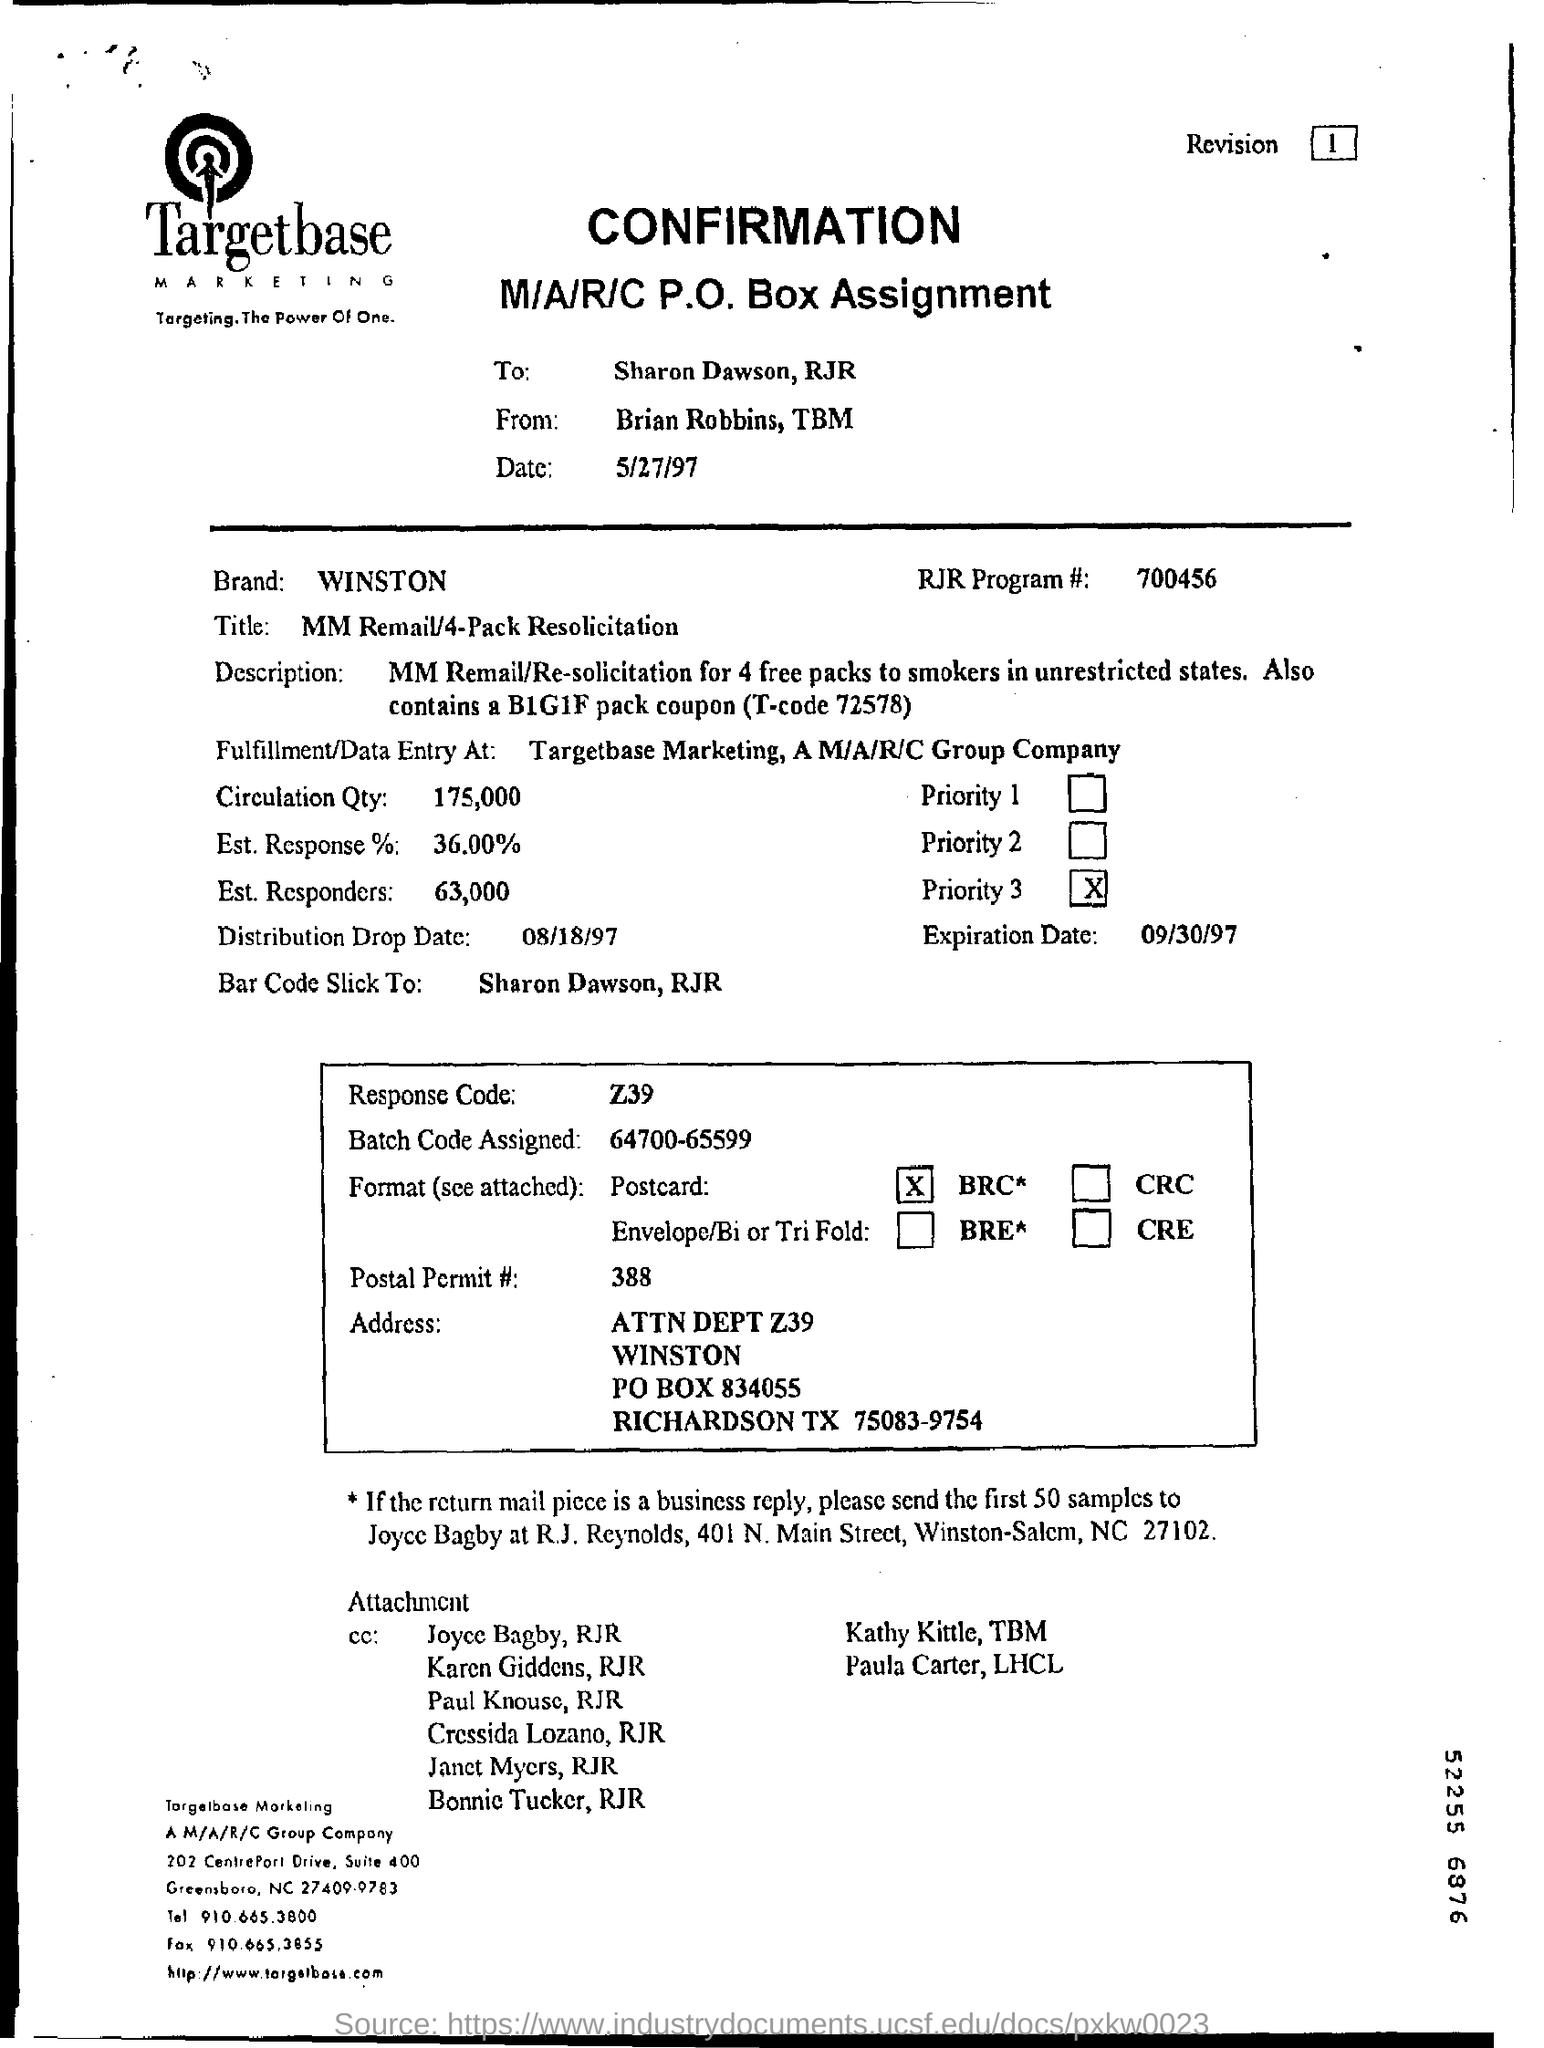What is the code for the rjr program?
Your answer should be compact. 700456. What is the response code ?
Give a very brief answer. Z39. 